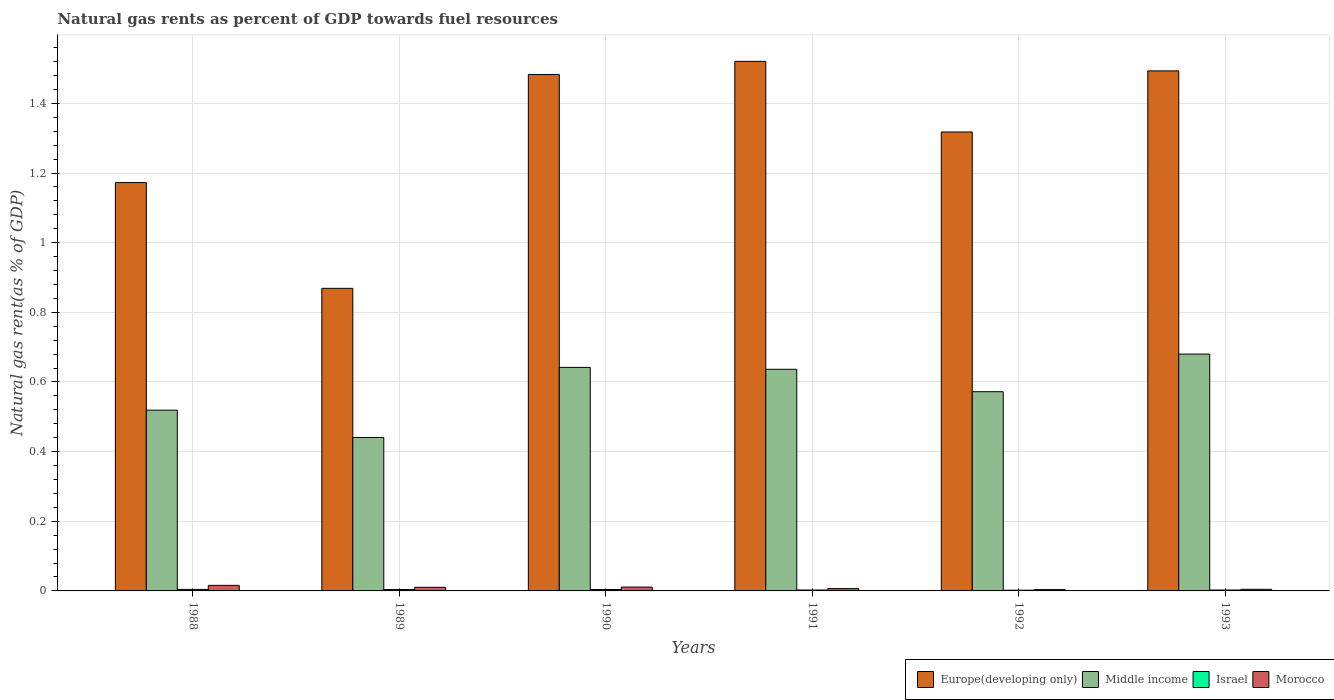Are the number of bars per tick equal to the number of legend labels?
Provide a short and direct response. Yes. Are the number of bars on each tick of the X-axis equal?
Make the answer very short. Yes. How many bars are there on the 5th tick from the right?
Provide a short and direct response. 4. What is the natural gas rent in Middle income in 1992?
Offer a terse response. 0.57. Across all years, what is the maximum natural gas rent in Morocco?
Ensure brevity in your answer.  0.02. Across all years, what is the minimum natural gas rent in Europe(developing only)?
Offer a very short reply. 0.87. In which year was the natural gas rent in Israel minimum?
Your answer should be compact. 1992. What is the total natural gas rent in Middle income in the graph?
Make the answer very short. 3.49. What is the difference between the natural gas rent in Israel in 1990 and that in 1993?
Your answer should be compact. 0. What is the difference between the natural gas rent in Europe(developing only) in 1992 and the natural gas rent in Morocco in 1990?
Keep it short and to the point. 1.31. What is the average natural gas rent in Europe(developing only) per year?
Your answer should be very brief. 1.31. In the year 1992, what is the difference between the natural gas rent in Middle income and natural gas rent in Israel?
Give a very brief answer. 0.57. What is the ratio of the natural gas rent in Israel in 1988 to that in 1990?
Your answer should be compact. 1.12. What is the difference between the highest and the second highest natural gas rent in Middle income?
Keep it short and to the point. 0.04. What is the difference between the highest and the lowest natural gas rent in Middle income?
Keep it short and to the point. 0.24. In how many years, is the natural gas rent in Israel greater than the average natural gas rent in Israel taken over all years?
Your answer should be compact. 3. Is the sum of the natural gas rent in Morocco in 1991 and 1993 greater than the maximum natural gas rent in Middle income across all years?
Your answer should be compact. No. What does the 1st bar from the left in 1988 represents?
Keep it short and to the point. Europe(developing only). What does the 1st bar from the right in 1990 represents?
Your answer should be very brief. Morocco. How many bars are there?
Provide a short and direct response. 24. Are the values on the major ticks of Y-axis written in scientific E-notation?
Give a very brief answer. No. Does the graph contain any zero values?
Provide a short and direct response. No. Where does the legend appear in the graph?
Your response must be concise. Bottom right. What is the title of the graph?
Offer a terse response. Natural gas rents as percent of GDP towards fuel resources. What is the label or title of the Y-axis?
Offer a very short reply. Natural gas rent(as % of GDP). What is the Natural gas rent(as % of GDP) in Europe(developing only) in 1988?
Offer a very short reply. 1.17. What is the Natural gas rent(as % of GDP) of Middle income in 1988?
Offer a terse response. 0.52. What is the Natural gas rent(as % of GDP) of Israel in 1988?
Your answer should be very brief. 0. What is the Natural gas rent(as % of GDP) of Morocco in 1988?
Your response must be concise. 0.02. What is the Natural gas rent(as % of GDP) in Europe(developing only) in 1989?
Make the answer very short. 0.87. What is the Natural gas rent(as % of GDP) of Middle income in 1989?
Give a very brief answer. 0.44. What is the Natural gas rent(as % of GDP) of Israel in 1989?
Offer a terse response. 0. What is the Natural gas rent(as % of GDP) in Morocco in 1989?
Make the answer very short. 0.01. What is the Natural gas rent(as % of GDP) in Europe(developing only) in 1990?
Keep it short and to the point. 1.48. What is the Natural gas rent(as % of GDP) of Middle income in 1990?
Ensure brevity in your answer.  0.64. What is the Natural gas rent(as % of GDP) in Israel in 1990?
Your answer should be compact. 0. What is the Natural gas rent(as % of GDP) in Morocco in 1990?
Provide a short and direct response. 0.01. What is the Natural gas rent(as % of GDP) in Europe(developing only) in 1991?
Your answer should be very brief. 1.52. What is the Natural gas rent(as % of GDP) in Middle income in 1991?
Provide a short and direct response. 0.64. What is the Natural gas rent(as % of GDP) in Israel in 1991?
Your answer should be very brief. 0. What is the Natural gas rent(as % of GDP) in Morocco in 1991?
Your answer should be compact. 0.01. What is the Natural gas rent(as % of GDP) of Europe(developing only) in 1992?
Your answer should be compact. 1.32. What is the Natural gas rent(as % of GDP) in Middle income in 1992?
Offer a very short reply. 0.57. What is the Natural gas rent(as % of GDP) in Israel in 1992?
Ensure brevity in your answer.  0. What is the Natural gas rent(as % of GDP) in Morocco in 1992?
Your answer should be compact. 0. What is the Natural gas rent(as % of GDP) of Europe(developing only) in 1993?
Keep it short and to the point. 1.49. What is the Natural gas rent(as % of GDP) in Middle income in 1993?
Provide a succinct answer. 0.68. What is the Natural gas rent(as % of GDP) of Israel in 1993?
Make the answer very short. 0. What is the Natural gas rent(as % of GDP) of Morocco in 1993?
Your answer should be very brief. 0. Across all years, what is the maximum Natural gas rent(as % of GDP) of Europe(developing only)?
Give a very brief answer. 1.52. Across all years, what is the maximum Natural gas rent(as % of GDP) in Middle income?
Make the answer very short. 0.68. Across all years, what is the maximum Natural gas rent(as % of GDP) of Israel?
Make the answer very short. 0. Across all years, what is the maximum Natural gas rent(as % of GDP) in Morocco?
Offer a very short reply. 0.02. Across all years, what is the minimum Natural gas rent(as % of GDP) in Europe(developing only)?
Your response must be concise. 0.87. Across all years, what is the minimum Natural gas rent(as % of GDP) in Middle income?
Provide a short and direct response. 0.44. Across all years, what is the minimum Natural gas rent(as % of GDP) of Israel?
Your answer should be very brief. 0. Across all years, what is the minimum Natural gas rent(as % of GDP) of Morocco?
Your answer should be compact. 0. What is the total Natural gas rent(as % of GDP) of Europe(developing only) in the graph?
Make the answer very short. 7.86. What is the total Natural gas rent(as % of GDP) of Middle income in the graph?
Ensure brevity in your answer.  3.49. What is the total Natural gas rent(as % of GDP) in Israel in the graph?
Your answer should be very brief. 0.02. What is the total Natural gas rent(as % of GDP) in Morocco in the graph?
Give a very brief answer. 0.05. What is the difference between the Natural gas rent(as % of GDP) of Europe(developing only) in 1988 and that in 1989?
Your answer should be very brief. 0.3. What is the difference between the Natural gas rent(as % of GDP) in Middle income in 1988 and that in 1989?
Provide a short and direct response. 0.08. What is the difference between the Natural gas rent(as % of GDP) of Israel in 1988 and that in 1989?
Your answer should be compact. 0. What is the difference between the Natural gas rent(as % of GDP) in Morocco in 1988 and that in 1989?
Keep it short and to the point. 0.01. What is the difference between the Natural gas rent(as % of GDP) in Europe(developing only) in 1988 and that in 1990?
Your answer should be very brief. -0.31. What is the difference between the Natural gas rent(as % of GDP) in Middle income in 1988 and that in 1990?
Provide a succinct answer. -0.12. What is the difference between the Natural gas rent(as % of GDP) of Morocco in 1988 and that in 1990?
Make the answer very short. 0. What is the difference between the Natural gas rent(as % of GDP) of Europe(developing only) in 1988 and that in 1991?
Your answer should be very brief. -0.35. What is the difference between the Natural gas rent(as % of GDP) of Middle income in 1988 and that in 1991?
Your answer should be very brief. -0.12. What is the difference between the Natural gas rent(as % of GDP) of Israel in 1988 and that in 1991?
Your response must be concise. 0. What is the difference between the Natural gas rent(as % of GDP) in Morocco in 1988 and that in 1991?
Offer a very short reply. 0.01. What is the difference between the Natural gas rent(as % of GDP) in Europe(developing only) in 1988 and that in 1992?
Ensure brevity in your answer.  -0.15. What is the difference between the Natural gas rent(as % of GDP) in Middle income in 1988 and that in 1992?
Provide a short and direct response. -0.05. What is the difference between the Natural gas rent(as % of GDP) in Israel in 1988 and that in 1992?
Provide a short and direct response. 0. What is the difference between the Natural gas rent(as % of GDP) in Morocco in 1988 and that in 1992?
Offer a very short reply. 0.01. What is the difference between the Natural gas rent(as % of GDP) of Europe(developing only) in 1988 and that in 1993?
Your answer should be very brief. -0.32. What is the difference between the Natural gas rent(as % of GDP) of Middle income in 1988 and that in 1993?
Ensure brevity in your answer.  -0.16. What is the difference between the Natural gas rent(as % of GDP) of Israel in 1988 and that in 1993?
Give a very brief answer. 0. What is the difference between the Natural gas rent(as % of GDP) of Morocco in 1988 and that in 1993?
Your answer should be very brief. 0.01. What is the difference between the Natural gas rent(as % of GDP) in Europe(developing only) in 1989 and that in 1990?
Give a very brief answer. -0.61. What is the difference between the Natural gas rent(as % of GDP) of Middle income in 1989 and that in 1990?
Your answer should be very brief. -0.2. What is the difference between the Natural gas rent(as % of GDP) of Israel in 1989 and that in 1990?
Offer a very short reply. -0. What is the difference between the Natural gas rent(as % of GDP) of Morocco in 1989 and that in 1990?
Keep it short and to the point. -0. What is the difference between the Natural gas rent(as % of GDP) in Europe(developing only) in 1989 and that in 1991?
Your answer should be very brief. -0.65. What is the difference between the Natural gas rent(as % of GDP) of Middle income in 1989 and that in 1991?
Offer a very short reply. -0.2. What is the difference between the Natural gas rent(as % of GDP) of Israel in 1989 and that in 1991?
Your answer should be very brief. 0. What is the difference between the Natural gas rent(as % of GDP) in Morocco in 1989 and that in 1991?
Give a very brief answer. 0. What is the difference between the Natural gas rent(as % of GDP) of Europe(developing only) in 1989 and that in 1992?
Provide a succinct answer. -0.45. What is the difference between the Natural gas rent(as % of GDP) in Middle income in 1989 and that in 1992?
Give a very brief answer. -0.13. What is the difference between the Natural gas rent(as % of GDP) in Israel in 1989 and that in 1992?
Offer a terse response. 0. What is the difference between the Natural gas rent(as % of GDP) in Morocco in 1989 and that in 1992?
Make the answer very short. 0.01. What is the difference between the Natural gas rent(as % of GDP) in Europe(developing only) in 1989 and that in 1993?
Ensure brevity in your answer.  -0.62. What is the difference between the Natural gas rent(as % of GDP) in Middle income in 1989 and that in 1993?
Your response must be concise. -0.24. What is the difference between the Natural gas rent(as % of GDP) in Israel in 1989 and that in 1993?
Your answer should be very brief. 0. What is the difference between the Natural gas rent(as % of GDP) of Morocco in 1989 and that in 1993?
Your answer should be very brief. 0.01. What is the difference between the Natural gas rent(as % of GDP) of Europe(developing only) in 1990 and that in 1991?
Make the answer very short. -0.04. What is the difference between the Natural gas rent(as % of GDP) in Middle income in 1990 and that in 1991?
Ensure brevity in your answer.  0.01. What is the difference between the Natural gas rent(as % of GDP) in Israel in 1990 and that in 1991?
Offer a very short reply. 0. What is the difference between the Natural gas rent(as % of GDP) of Morocco in 1990 and that in 1991?
Offer a terse response. 0. What is the difference between the Natural gas rent(as % of GDP) in Europe(developing only) in 1990 and that in 1992?
Provide a succinct answer. 0.17. What is the difference between the Natural gas rent(as % of GDP) in Middle income in 1990 and that in 1992?
Make the answer very short. 0.07. What is the difference between the Natural gas rent(as % of GDP) of Israel in 1990 and that in 1992?
Your answer should be compact. 0. What is the difference between the Natural gas rent(as % of GDP) in Morocco in 1990 and that in 1992?
Your answer should be very brief. 0.01. What is the difference between the Natural gas rent(as % of GDP) of Europe(developing only) in 1990 and that in 1993?
Your answer should be very brief. -0.01. What is the difference between the Natural gas rent(as % of GDP) in Middle income in 1990 and that in 1993?
Your answer should be compact. -0.04. What is the difference between the Natural gas rent(as % of GDP) in Israel in 1990 and that in 1993?
Your answer should be very brief. 0. What is the difference between the Natural gas rent(as % of GDP) of Morocco in 1990 and that in 1993?
Your answer should be compact. 0.01. What is the difference between the Natural gas rent(as % of GDP) in Europe(developing only) in 1991 and that in 1992?
Ensure brevity in your answer.  0.2. What is the difference between the Natural gas rent(as % of GDP) of Middle income in 1991 and that in 1992?
Ensure brevity in your answer.  0.06. What is the difference between the Natural gas rent(as % of GDP) of Israel in 1991 and that in 1992?
Your answer should be very brief. 0. What is the difference between the Natural gas rent(as % of GDP) of Morocco in 1991 and that in 1992?
Give a very brief answer. 0. What is the difference between the Natural gas rent(as % of GDP) in Europe(developing only) in 1991 and that in 1993?
Your answer should be very brief. 0.03. What is the difference between the Natural gas rent(as % of GDP) in Middle income in 1991 and that in 1993?
Provide a short and direct response. -0.04. What is the difference between the Natural gas rent(as % of GDP) in Morocco in 1991 and that in 1993?
Your response must be concise. 0. What is the difference between the Natural gas rent(as % of GDP) of Europe(developing only) in 1992 and that in 1993?
Give a very brief answer. -0.18. What is the difference between the Natural gas rent(as % of GDP) in Middle income in 1992 and that in 1993?
Your answer should be very brief. -0.11. What is the difference between the Natural gas rent(as % of GDP) of Israel in 1992 and that in 1993?
Your response must be concise. -0. What is the difference between the Natural gas rent(as % of GDP) in Morocco in 1992 and that in 1993?
Provide a short and direct response. -0. What is the difference between the Natural gas rent(as % of GDP) of Europe(developing only) in 1988 and the Natural gas rent(as % of GDP) of Middle income in 1989?
Give a very brief answer. 0.73. What is the difference between the Natural gas rent(as % of GDP) in Europe(developing only) in 1988 and the Natural gas rent(as % of GDP) in Israel in 1989?
Your answer should be very brief. 1.17. What is the difference between the Natural gas rent(as % of GDP) of Europe(developing only) in 1988 and the Natural gas rent(as % of GDP) of Morocco in 1989?
Offer a very short reply. 1.16. What is the difference between the Natural gas rent(as % of GDP) of Middle income in 1988 and the Natural gas rent(as % of GDP) of Israel in 1989?
Your response must be concise. 0.52. What is the difference between the Natural gas rent(as % of GDP) of Middle income in 1988 and the Natural gas rent(as % of GDP) of Morocco in 1989?
Your answer should be very brief. 0.51. What is the difference between the Natural gas rent(as % of GDP) of Israel in 1988 and the Natural gas rent(as % of GDP) of Morocco in 1989?
Make the answer very short. -0.01. What is the difference between the Natural gas rent(as % of GDP) of Europe(developing only) in 1988 and the Natural gas rent(as % of GDP) of Middle income in 1990?
Offer a very short reply. 0.53. What is the difference between the Natural gas rent(as % of GDP) of Europe(developing only) in 1988 and the Natural gas rent(as % of GDP) of Israel in 1990?
Provide a succinct answer. 1.17. What is the difference between the Natural gas rent(as % of GDP) of Europe(developing only) in 1988 and the Natural gas rent(as % of GDP) of Morocco in 1990?
Provide a short and direct response. 1.16. What is the difference between the Natural gas rent(as % of GDP) of Middle income in 1988 and the Natural gas rent(as % of GDP) of Israel in 1990?
Ensure brevity in your answer.  0.52. What is the difference between the Natural gas rent(as % of GDP) of Middle income in 1988 and the Natural gas rent(as % of GDP) of Morocco in 1990?
Provide a succinct answer. 0.51. What is the difference between the Natural gas rent(as % of GDP) in Israel in 1988 and the Natural gas rent(as % of GDP) in Morocco in 1990?
Make the answer very short. -0.01. What is the difference between the Natural gas rent(as % of GDP) of Europe(developing only) in 1988 and the Natural gas rent(as % of GDP) of Middle income in 1991?
Your answer should be very brief. 0.54. What is the difference between the Natural gas rent(as % of GDP) in Europe(developing only) in 1988 and the Natural gas rent(as % of GDP) in Israel in 1991?
Ensure brevity in your answer.  1.17. What is the difference between the Natural gas rent(as % of GDP) in Europe(developing only) in 1988 and the Natural gas rent(as % of GDP) in Morocco in 1991?
Your answer should be compact. 1.17. What is the difference between the Natural gas rent(as % of GDP) in Middle income in 1988 and the Natural gas rent(as % of GDP) in Israel in 1991?
Offer a very short reply. 0.52. What is the difference between the Natural gas rent(as % of GDP) in Middle income in 1988 and the Natural gas rent(as % of GDP) in Morocco in 1991?
Your answer should be very brief. 0.51. What is the difference between the Natural gas rent(as % of GDP) in Israel in 1988 and the Natural gas rent(as % of GDP) in Morocco in 1991?
Offer a terse response. -0. What is the difference between the Natural gas rent(as % of GDP) of Europe(developing only) in 1988 and the Natural gas rent(as % of GDP) of Middle income in 1992?
Make the answer very short. 0.6. What is the difference between the Natural gas rent(as % of GDP) of Europe(developing only) in 1988 and the Natural gas rent(as % of GDP) of Israel in 1992?
Provide a short and direct response. 1.17. What is the difference between the Natural gas rent(as % of GDP) of Europe(developing only) in 1988 and the Natural gas rent(as % of GDP) of Morocco in 1992?
Give a very brief answer. 1.17. What is the difference between the Natural gas rent(as % of GDP) in Middle income in 1988 and the Natural gas rent(as % of GDP) in Israel in 1992?
Offer a terse response. 0.52. What is the difference between the Natural gas rent(as % of GDP) in Middle income in 1988 and the Natural gas rent(as % of GDP) in Morocco in 1992?
Your answer should be very brief. 0.52. What is the difference between the Natural gas rent(as % of GDP) in Israel in 1988 and the Natural gas rent(as % of GDP) in Morocco in 1992?
Your response must be concise. 0. What is the difference between the Natural gas rent(as % of GDP) of Europe(developing only) in 1988 and the Natural gas rent(as % of GDP) of Middle income in 1993?
Keep it short and to the point. 0.49. What is the difference between the Natural gas rent(as % of GDP) in Europe(developing only) in 1988 and the Natural gas rent(as % of GDP) in Israel in 1993?
Provide a succinct answer. 1.17. What is the difference between the Natural gas rent(as % of GDP) of Europe(developing only) in 1988 and the Natural gas rent(as % of GDP) of Morocco in 1993?
Provide a short and direct response. 1.17. What is the difference between the Natural gas rent(as % of GDP) of Middle income in 1988 and the Natural gas rent(as % of GDP) of Israel in 1993?
Provide a succinct answer. 0.52. What is the difference between the Natural gas rent(as % of GDP) of Middle income in 1988 and the Natural gas rent(as % of GDP) of Morocco in 1993?
Your answer should be very brief. 0.51. What is the difference between the Natural gas rent(as % of GDP) of Israel in 1988 and the Natural gas rent(as % of GDP) of Morocco in 1993?
Give a very brief answer. -0. What is the difference between the Natural gas rent(as % of GDP) in Europe(developing only) in 1989 and the Natural gas rent(as % of GDP) in Middle income in 1990?
Keep it short and to the point. 0.23. What is the difference between the Natural gas rent(as % of GDP) of Europe(developing only) in 1989 and the Natural gas rent(as % of GDP) of Israel in 1990?
Your answer should be compact. 0.86. What is the difference between the Natural gas rent(as % of GDP) in Europe(developing only) in 1989 and the Natural gas rent(as % of GDP) in Morocco in 1990?
Provide a short and direct response. 0.86. What is the difference between the Natural gas rent(as % of GDP) of Middle income in 1989 and the Natural gas rent(as % of GDP) of Israel in 1990?
Keep it short and to the point. 0.44. What is the difference between the Natural gas rent(as % of GDP) in Middle income in 1989 and the Natural gas rent(as % of GDP) in Morocco in 1990?
Ensure brevity in your answer.  0.43. What is the difference between the Natural gas rent(as % of GDP) in Israel in 1989 and the Natural gas rent(as % of GDP) in Morocco in 1990?
Your response must be concise. -0.01. What is the difference between the Natural gas rent(as % of GDP) of Europe(developing only) in 1989 and the Natural gas rent(as % of GDP) of Middle income in 1991?
Keep it short and to the point. 0.23. What is the difference between the Natural gas rent(as % of GDP) of Europe(developing only) in 1989 and the Natural gas rent(as % of GDP) of Israel in 1991?
Keep it short and to the point. 0.87. What is the difference between the Natural gas rent(as % of GDP) of Europe(developing only) in 1989 and the Natural gas rent(as % of GDP) of Morocco in 1991?
Offer a terse response. 0.86. What is the difference between the Natural gas rent(as % of GDP) of Middle income in 1989 and the Natural gas rent(as % of GDP) of Israel in 1991?
Make the answer very short. 0.44. What is the difference between the Natural gas rent(as % of GDP) in Middle income in 1989 and the Natural gas rent(as % of GDP) in Morocco in 1991?
Your response must be concise. 0.43. What is the difference between the Natural gas rent(as % of GDP) in Israel in 1989 and the Natural gas rent(as % of GDP) in Morocco in 1991?
Give a very brief answer. -0. What is the difference between the Natural gas rent(as % of GDP) of Europe(developing only) in 1989 and the Natural gas rent(as % of GDP) of Middle income in 1992?
Offer a very short reply. 0.3. What is the difference between the Natural gas rent(as % of GDP) in Europe(developing only) in 1989 and the Natural gas rent(as % of GDP) in Israel in 1992?
Offer a terse response. 0.87. What is the difference between the Natural gas rent(as % of GDP) in Europe(developing only) in 1989 and the Natural gas rent(as % of GDP) in Morocco in 1992?
Offer a terse response. 0.87. What is the difference between the Natural gas rent(as % of GDP) of Middle income in 1989 and the Natural gas rent(as % of GDP) of Israel in 1992?
Your answer should be very brief. 0.44. What is the difference between the Natural gas rent(as % of GDP) of Middle income in 1989 and the Natural gas rent(as % of GDP) of Morocco in 1992?
Offer a very short reply. 0.44. What is the difference between the Natural gas rent(as % of GDP) of Europe(developing only) in 1989 and the Natural gas rent(as % of GDP) of Middle income in 1993?
Provide a succinct answer. 0.19. What is the difference between the Natural gas rent(as % of GDP) of Europe(developing only) in 1989 and the Natural gas rent(as % of GDP) of Israel in 1993?
Provide a short and direct response. 0.87. What is the difference between the Natural gas rent(as % of GDP) in Europe(developing only) in 1989 and the Natural gas rent(as % of GDP) in Morocco in 1993?
Provide a succinct answer. 0.86. What is the difference between the Natural gas rent(as % of GDP) in Middle income in 1989 and the Natural gas rent(as % of GDP) in Israel in 1993?
Offer a very short reply. 0.44. What is the difference between the Natural gas rent(as % of GDP) of Middle income in 1989 and the Natural gas rent(as % of GDP) of Morocco in 1993?
Offer a terse response. 0.44. What is the difference between the Natural gas rent(as % of GDP) of Israel in 1989 and the Natural gas rent(as % of GDP) of Morocco in 1993?
Keep it short and to the point. -0. What is the difference between the Natural gas rent(as % of GDP) in Europe(developing only) in 1990 and the Natural gas rent(as % of GDP) in Middle income in 1991?
Provide a succinct answer. 0.85. What is the difference between the Natural gas rent(as % of GDP) in Europe(developing only) in 1990 and the Natural gas rent(as % of GDP) in Israel in 1991?
Provide a succinct answer. 1.48. What is the difference between the Natural gas rent(as % of GDP) in Europe(developing only) in 1990 and the Natural gas rent(as % of GDP) in Morocco in 1991?
Keep it short and to the point. 1.48. What is the difference between the Natural gas rent(as % of GDP) in Middle income in 1990 and the Natural gas rent(as % of GDP) in Israel in 1991?
Your answer should be very brief. 0.64. What is the difference between the Natural gas rent(as % of GDP) of Middle income in 1990 and the Natural gas rent(as % of GDP) of Morocco in 1991?
Offer a very short reply. 0.64. What is the difference between the Natural gas rent(as % of GDP) of Israel in 1990 and the Natural gas rent(as % of GDP) of Morocco in 1991?
Your response must be concise. -0. What is the difference between the Natural gas rent(as % of GDP) of Europe(developing only) in 1990 and the Natural gas rent(as % of GDP) of Middle income in 1992?
Provide a short and direct response. 0.91. What is the difference between the Natural gas rent(as % of GDP) of Europe(developing only) in 1990 and the Natural gas rent(as % of GDP) of Israel in 1992?
Provide a short and direct response. 1.48. What is the difference between the Natural gas rent(as % of GDP) of Europe(developing only) in 1990 and the Natural gas rent(as % of GDP) of Morocco in 1992?
Make the answer very short. 1.48. What is the difference between the Natural gas rent(as % of GDP) in Middle income in 1990 and the Natural gas rent(as % of GDP) in Israel in 1992?
Provide a short and direct response. 0.64. What is the difference between the Natural gas rent(as % of GDP) in Middle income in 1990 and the Natural gas rent(as % of GDP) in Morocco in 1992?
Provide a short and direct response. 0.64. What is the difference between the Natural gas rent(as % of GDP) of Israel in 1990 and the Natural gas rent(as % of GDP) of Morocco in 1992?
Your answer should be very brief. 0. What is the difference between the Natural gas rent(as % of GDP) in Europe(developing only) in 1990 and the Natural gas rent(as % of GDP) in Middle income in 1993?
Your answer should be compact. 0.8. What is the difference between the Natural gas rent(as % of GDP) of Europe(developing only) in 1990 and the Natural gas rent(as % of GDP) of Israel in 1993?
Keep it short and to the point. 1.48. What is the difference between the Natural gas rent(as % of GDP) of Europe(developing only) in 1990 and the Natural gas rent(as % of GDP) of Morocco in 1993?
Your answer should be compact. 1.48. What is the difference between the Natural gas rent(as % of GDP) in Middle income in 1990 and the Natural gas rent(as % of GDP) in Israel in 1993?
Keep it short and to the point. 0.64. What is the difference between the Natural gas rent(as % of GDP) in Middle income in 1990 and the Natural gas rent(as % of GDP) in Morocco in 1993?
Make the answer very short. 0.64. What is the difference between the Natural gas rent(as % of GDP) in Israel in 1990 and the Natural gas rent(as % of GDP) in Morocco in 1993?
Your answer should be very brief. -0. What is the difference between the Natural gas rent(as % of GDP) of Europe(developing only) in 1991 and the Natural gas rent(as % of GDP) of Middle income in 1992?
Ensure brevity in your answer.  0.95. What is the difference between the Natural gas rent(as % of GDP) of Europe(developing only) in 1991 and the Natural gas rent(as % of GDP) of Israel in 1992?
Your answer should be very brief. 1.52. What is the difference between the Natural gas rent(as % of GDP) of Europe(developing only) in 1991 and the Natural gas rent(as % of GDP) of Morocco in 1992?
Give a very brief answer. 1.52. What is the difference between the Natural gas rent(as % of GDP) in Middle income in 1991 and the Natural gas rent(as % of GDP) in Israel in 1992?
Ensure brevity in your answer.  0.63. What is the difference between the Natural gas rent(as % of GDP) of Middle income in 1991 and the Natural gas rent(as % of GDP) of Morocco in 1992?
Offer a terse response. 0.63. What is the difference between the Natural gas rent(as % of GDP) of Israel in 1991 and the Natural gas rent(as % of GDP) of Morocco in 1992?
Ensure brevity in your answer.  -0. What is the difference between the Natural gas rent(as % of GDP) in Europe(developing only) in 1991 and the Natural gas rent(as % of GDP) in Middle income in 1993?
Your answer should be compact. 0.84. What is the difference between the Natural gas rent(as % of GDP) of Europe(developing only) in 1991 and the Natural gas rent(as % of GDP) of Israel in 1993?
Provide a succinct answer. 1.52. What is the difference between the Natural gas rent(as % of GDP) of Europe(developing only) in 1991 and the Natural gas rent(as % of GDP) of Morocco in 1993?
Offer a terse response. 1.52. What is the difference between the Natural gas rent(as % of GDP) of Middle income in 1991 and the Natural gas rent(as % of GDP) of Israel in 1993?
Your answer should be compact. 0.63. What is the difference between the Natural gas rent(as % of GDP) in Middle income in 1991 and the Natural gas rent(as % of GDP) in Morocco in 1993?
Ensure brevity in your answer.  0.63. What is the difference between the Natural gas rent(as % of GDP) of Israel in 1991 and the Natural gas rent(as % of GDP) of Morocco in 1993?
Keep it short and to the point. -0. What is the difference between the Natural gas rent(as % of GDP) of Europe(developing only) in 1992 and the Natural gas rent(as % of GDP) of Middle income in 1993?
Offer a terse response. 0.64. What is the difference between the Natural gas rent(as % of GDP) of Europe(developing only) in 1992 and the Natural gas rent(as % of GDP) of Israel in 1993?
Provide a short and direct response. 1.32. What is the difference between the Natural gas rent(as % of GDP) of Europe(developing only) in 1992 and the Natural gas rent(as % of GDP) of Morocco in 1993?
Your answer should be very brief. 1.31. What is the difference between the Natural gas rent(as % of GDP) in Middle income in 1992 and the Natural gas rent(as % of GDP) in Israel in 1993?
Give a very brief answer. 0.57. What is the difference between the Natural gas rent(as % of GDP) in Middle income in 1992 and the Natural gas rent(as % of GDP) in Morocco in 1993?
Your response must be concise. 0.57. What is the difference between the Natural gas rent(as % of GDP) of Israel in 1992 and the Natural gas rent(as % of GDP) of Morocco in 1993?
Offer a very short reply. -0. What is the average Natural gas rent(as % of GDP) in Europe(developing only) per year?
Make the answer very short. 1.31. What is the average Natural gas rent(as % of GDP) in Middle income per year?
Provide a short and direct response. 0.58. What is the average Natural gas rent(as % of GDP) of Israel per year?
Make the answer very short. 0. What is the average Natural gas rent(as % of GDP) in Morocco per year?
Provide a short and direct response. 0.01. In the year 1988, what is the difference between the Natural gas rent(as % of GDP) of Europe(developing only) and Natural gas rent(as % of GDP) of Middle income?
Provide a succinct answer. 0.65. In the year 1988, what is the difference between the Natural gas rent(as % of GDP) in Europe(developing only) and Natural gas rent(as % of GDP) in Israel?
Your answer should be very brief. 1.17. In the year 1988, what is the difference between the Natural gas rent(as % of GDP) of Europe(developing only) and Natural gas rent(as % of GDP) of Morocco?
Your response must be concise. 1.16. In the year 1988, what is the difference between the Natural gas rent(as % of GDP) in Middle income and Natural gas rent(as % of GDP) in Israel?
Make the answer very short. 0.51. In the year 1988, what is the difference between the Natural gas rent(as % of GDP) of Middle income and Natural gas rent(as % of GDP) of Morocco?
Give a very brief answer. 0.5. In the year 1988, what is the difference between the Natural gas rent(as % of GDP) of Israel and Natural gas rent(as % of GDP) of Morocco?
Give a very brief answer. -0.01. In the year 1989, what is the difference between the Natural gas rent(as % of GDP) in Europe(developing only) and Natural gas rent(as % of GDP) in Middle income?
Offer a very short reply. 0.43. In the year 1989, what is the difference between the Natural gas rent(as % of GDP) in Europe(developing only) and Natural gas rent(as % of GDP) in Israel?
Your answer should be very brief. 0.86. In the year 1989, what is the difference between the Natural gas rent(as % of GDP) in Europe(developing only) and Natural gas rent(as % of GDP) in Morocco?
Offer a very short reply. 0.86. In the year 1989, what is the difference between the Natural gas rent(as % of GDP) in Middle income and Natural gas rent(as % of GDP) in Israel?
Your answer should be very brief. 0.44. In the year 1989, what is the difference between the Natural gas rent(as % of GDP) in Middle income and Natural gas rent(as % of GDP) in Morocco?
Give a very brief answer. 0.43. In the year 1989, what is the difference between the Natural gas rent(as % of GDP) of Israel and Natural gas rent(as % of GDP) of Morocco?
Offer a terse response. -0.01. In the year 1990, what is the difference between the Natural gas rent(as % of GDP) in Europe(developing only) and Natural gas rent(as % of GDP) in Middle income?
Your response must be concise. 0.84. In the year 1990, what is the difference between the Natural gas rent(as % of GDP) in Europe(developing only) and Natural gas rent(as % of GDP) in Israel?
Give a very brief answer. 1.48. In the year 1990, what is the difference between the Natural gas rent(as % of GDP) in Europe(developing only) and Natural gas rent(as % of GDP) in Morocco?
Your response must be concise. 1.47. In the year 1990, what is the difference between the Natural gas rent(as % of GDP) of Middle income and Natural gas rent(as % of GDP) of Israel?
Keep it short and to the point. 0.64. In the year 1990, what is the difference between the Natural gas rent(as % of GDP) of Middle income and Natural gas rent(as % of GDP) of Morocco?
Your answer should be very brief. 0.63. In the year 1990, what is the difference between the Natural gas rent(as % of GDP) in Israel and Natural gas rent(as % of GDP) in Morocco?
Ensure brevity in your answer.  -0.01. In the year 1991, what is the difference between the Natural gas rent(as % of GDP) in Europe(developing only) and Natural gas rent(as % of GDP) in Middle income?
Make the answer very short. 0.88. In the year 1991, what is the difference between the Natural gas rent(as % of GDP) of Europe(developing only) and Natural gas rent(as % of GDP) of Israel?
Your answer should be very brief. 1.52. In the year 1991, what is the difference between the Natural gas rent(as % of GDP) of Europe(developing only) and Natural gas rent(as % of GDP) of Morocco?
Your answer should be compact. 1.51. In the year 1991, what is the difference between the Natural gas rent(as % of GDP) of Middle income and Natural gas rent(as % of GDP) of Israel?
Keep it short and to the point. 0.63. In the year 1991, what is the difference between the Natural gas rent(as % of GDP) in Middle income and Natural gas rent(as % of GDP) in Morocco?
Offer a terse response. 0.63. In the year 1991, what is the difference between the Natural gas rent(as % of GDP) of Israel and Natural gas rent(as % of GDP) of Morocco?
Your response must be concise. -0. In the year 1992, what is the difference between the Natural gas rent(as % of GDP) of Europe(developing only) and Natural gas rent(as % of GDP) of Middle income?
Offer a very short reply. 0.75. In the year 1992, what is the difference between the Natural gas rent(as % of GDP) in Europe(developing only) and Natural gas rent(as % of GDP) in Israel?
Give a very brief answer. 1.32. In the year 1992, what is the difference between the Natural gas rent(as % of GDP) in Europe(developing only) and Natural gas rent(as % of GDP) in Morocco?
Your answer should be compact. 1.31. In the year 1992, what is the difference between the Natural gas rent(as % of GDP) in Middle income and Natural gas rent(as % of GDP) in Israel?
Offer a terse response. 0.57. In the year 1992, what is the difference between the Natural gas rent(as % of GDP) in Middle income and Natural gas rent(as % of GDP) in Morocco?
Offer a terse response. 0.57. In the year 1992, what is the difference between the Natural gas rent(as % of GDP) in Israel and Natural gas rent(as % of GDP) in Morocco?
Offer a very short reply. -0. In the year 1993, what is the difference between the Natural gas rent(as % of GDP) in Europe(developing only) and Natural gas rent(as % of GDP) in Middle income?
Your answer should be compact. 0.81. In the year 1993, what is the difference between the Natural gas rent(as % of GDP) of Europe(developing only) and Natural gas rent(as % of GDP) of Israel?
Provide a succinct answer. 1.49. In the year 1993, what is the difference between the Natural gas rent(as % of GDP) of Europe(developing only) and Natural gas rent(as % of GDP) of Morocco?
Offer a terse response. 1.49. In the year 1993, what is the difference between the Natural gas rent(as % of GDP) in Middle income and Natural gas rent(as % of GDP) in Israel?
Make the answer very short. 0.68. In the year 1993, what is the difference between the Natural gas rent(as % of GDP) of Middle income and Natural gas rent(as % of GDP) of Morocco?
Your answer should be compact. 0.68. In the year 1993, what is the difference between the Natural gas rent(as % of GDP) of Israel and Natural gas rent(as % of GDP) of Morocco?
Keep it short and to the point. -0. What is the ratio of the Natural gas rent(as % of GDP) in Europe(developing only) in 1988 to that in 1989?
Your answer should be very brief. 1.35. What is the ratio of the Natural gas rent(as % of GDP) of Middle income in 1988 to that in 1989?
Make the answer very short. 1.18. What is the ratio of the Natural gas rent(as % of GDP) of Israel in 1988 to that in 1989?
Give a very brief answer. 1.12. What is the ratio of the Natural gas rent(as % of GDP) in Morocco in 1988 to that in 1989?
Your response must be concise. 1.54. What is the ratio of the Natural gas rent(as % of GDP) in Europe(developing only) in 1988 to that in 1990?
Give a very brief answer. 0.79. What is the ratio of the Natural gas rent(as % of GDP) in Middle income in 1988 to that in 1990?
Offer a very short reply. 0.81. What is the ratio of the Natural gas rent(as % of GDP) of Israel in 1988 to that in 1990?
Your response must be concise. 1.12. What is the ratio of the Natural gas rent(as % of GDP) in Morocco in 1988 to that in 1990?
Offer a very short reply. 1.45. What is the ratio of the Natural gas rent(as % of GDP) in Europe(developing only) in 1988 to that in 1991?
Offer a very short reply. 0.77. What is the ratio of the Natural gas rent(as % of GDP) in Middle income in 1988 to that in 1991?
Give a very brief answer. 0.82. What is the ratio of the Natural gas rent(as % of GDP) in Israel in 1988 to that in 1991?
Provide a short and direct response. 1.69. What is the ratio of the Natural gas rent(as % of GDP) in Morocco in 1988 to that in 1991?
Make the answer very short. 2.39. What is the ratio of the Natural gas rent(as % of GDP) of Europe(developing only) in 1988 to that in 1992?
Provide a short and direct response. 0.89. What is the ratio of the Natural gas rent(as % of GDP) of Middle income in 1988 to that in 1992?
Make the answer very short. 0.91. What is the ratio of the Natural gas rent(as % of GDP) of Israel in 1988 to that in 1992?
Keep it short and to the point. 2.12. What is the ratio of the Natural gas rent(as % of GDP) in Morocco in 1988 to that in 1992?
Offer a very short reply. 4.19. What is the ratio of the Natural gas rent(as % of GDP) in Europe(developing only) in 1988 to that in 1993?
Your answer should be compact. 0.79. What is the ratio of the Natural gas rent(as % of GDP) in Middle income in 1988 to that in 1993?
Offer a very short reply. 0.76. What is the ratio of the Natural gas rent(as % of GDP) in Israel in 1988 to that in 1993?
Ensure brevity in your answer.  1.71. What is the ratio of the Natural gas rent(as % of GDP) in Morocco in 1988 to that in 1993?
Offer a terse response. 3.42. What is the ratio of the Natural gas rent(as % of GDP) of Europe(developing only) in 1989 to that in 1990?
Your response must be concise. 0.59. What is the ratio of the Natural gas rent(as % of GDP) of Middle income in 1989 to that in 1990?
Give a very brief answer. 0.69. What is the ratio of the Natural gas rent(as % of GDP) of Israel in 1989 to that in 1990?
Make the answer very short. 1. What is the ratio of the Natural gas rent(as % of GDP) in Morocco in 1989 to that in 1990?
Offer a very short reply. 0.94. What is the ratio of the Natural gas rent(as % of GDP) of Europe(developing only) in 1989 to that in 1991?
Ensure brevity in your answer.  0.57. What is the ratio of the Natural gas rent(as % of GDP) in Middle income in 1989 to that in 1991?
Your answer should be compact. 0.69. What is the ratio of the Natural gas rent(as % of GDP) in Israel in 1989 to that in 1991?
Provide a succinct answer. 1.51. What is the ratio of the Natural gas rent(as % of GDP) of Morocco in 1989 to that in 1991?
Ensure brevity in your answer.  1.56. What is the ratio of the Natural gas rent(as % of GDP) of Europe(developing only) in 1989 to that in 1992?
Your answer should be compact. 0.66. What is the ratio of the Natural gas rent(as % of GDP) of Middle income in 1989 to that in 1992?
Provide a short and direct response. 0.77. What is the ratio of the Natural gas rent(as % of GDP) in Israel in 1989 to that in 1992?
Ensure brevity in your answer.  1.89. What is the ratio of the Natural gas rent(as % of GDP) of Morocco in 1989 to that in 1992?
Provide a short and direct response. 2.73. What is the ratio of the Natural gas rent(as % of GDP) in Europe(developing only) in 1989 to that in 1993?
Ensure brevity in your answer.  0.58. What is the ratio of the Natural gas rent(as % of GDP) in Middle income in 1989 to that in 1993?
Your answer should be very brief. 0.65. What is the ratio of the Natural gas rent(as % of GDP) in Israel in 1989 to that in 1993?
Offer a terse response. 1.52. What is the ratio of the Natural gas rent(as % of GDP) of Morocco in 1989 to that in 1993?
Give a very brief answer. 2.23. What is the ratio of the Natural gas rent(as % of GDP) of Europe(developing only) in 1990 to that in 1991?
Keep it short and to the point. 0.98. What is the ratio of the Natural gas rent(as % of GDP) in Middle income in 1990 to that in 1991?
Keep it short and to the point. 1.01. What is the ratio of the Natural gas rent(as % of GDP) of Israel in 1990 to that in 1991?
Give a very brief answer. 1.51. What is the ratio of the Natural gas rent(as % of GDP) of Morocco in 1990 to that in 1991?
Your answer should be compact. 1.65. What is the ratio of the Natural gas rent(as % of GDP) in Europe(developing only) in 1990 to that in 1992?
Offer a very short reply. 1.13. What is the ratio of the Natural gas rent(as % of GDP) of Middle income in 1990 to that in 1992?
Your answer should be compact. 1.12. What is the ratio of the Natural gas rent(as % of GDP) of Israel in 1990 to that in 1992?
Your answer should be very brief. 1.9. What is the ratio of the Natural gas rent(as % of GDP) of Morocco in 1990 to that in 1992?
Provide a succinct answer. 2.89. What is the ratio of the Natural gas rent(as % of GDP) in Europe(developing only) in 1990 to that in 1993?
Provide a short and direct response. 0.99. What is the ratio of the Natural gas rent(as % of GDP) in Middle income in 1990 to that in 1993?
Your response must be concise. 0.94. What is the ratio of the Natural gas rent(as % of GDP) in Israel in 1990 to that in 1993?
Provide a short and direct response. 1.53. What is the ratio of the Natural gas rent(as % of GDP) in Morocco in 1990 to that in 1993?
Provide a succinct answer. 2.36. What is the ratio of the Natural gas rent(as % of GDP) of Europe(developing only) in 1991 to that in 1992?
Offer a very short reply. 1.15. What is the ratio of the Natural gas rent(as % of GDP) of Middle income in 1991 to that in 1992?
Your answer should be compact. 1.11. What is the ratio of the Natural gas rent(as % of GDP) in Israel in 1991 to that in 1992?
Your answer should be very brief. 1.26. What is the ratio of the Natural gas rent(as % of GDP) in Morocco in 1991 to that in 1992?
Make the answer very short. 1.75. What is the ratio of the Natural gas rent(as % of GDP) of Europe(developing only) in 1991 to that in 1993?
Keep it short and to the point. 1.02. What is the ratio of the Natural gas rent(as % of GDP) in Middle income in 1991 to that in 1993?
Keep it short and to the point. 0.94. What is the ratio of the Natural gas rent(as % of GDP) in Israel in 1991 to that in 1993?
Your answer should be very brief. 1.01. What is the ratio of the Natural gas rent(as % of GDP) in Morocco in 1991 to that in 1993?
Your response must be concise. 1.43. What is the ratio of the Natural gas rent(as % of GDP) in Europe(developing only) in 1992 to that in 1993?
Provide a succinct answer. 0.88. What is the ratio of the Natural gas rent(as % of GDP) in Middle income in 1992 to that in 1993?
Provide a succinct answer. 0.84. What is the ratio of the Natural gas rent(as % of GDP) in Israel in 1992 to that in 1993?
Ensure brevity in your answer.  0.81. What is the ratio of the Natural gas rent(as % of GDP) of Morocco in 1992 to that in 1993?
Ensure brevity in your answer.  0.82. What is the difference between the highest and the second highest Natural gas rent(as % of GDP) of Europe(developing only)?
Offer a terse response. 0.03. What is the difference between the highest and the second highest Natural gas rent(as % of GDP) in Middle income?
Offer a terse response. 0.04. What is the difference between the highest and the second highest Natural gas rent(as % of GDP) in Israel?
Provide a succinct answer. 0. What is the difference between the highest and the second highest Natural gas rent(as % of GDP) of Morocco?
Make the answer very short. 0. What is the difference between the highest and the lowest Natural gas rent(as % of GDP) of Europe(developing only)?
Offer a very short reply. 0.65. What is the difference between the highest and the lowest Natural gas rent(as % of GDP) in Middle income?
Offer a terse response. 0.24. What is the difference between the highest and the lowest Natural gas rent(as % of GDP) of Israel?
Give a very brief answer. 0. What is the difference between the highest and the lowest Natural gas rent(as % of GDP) in Morocco?
Make the answer very short. 0.01. 